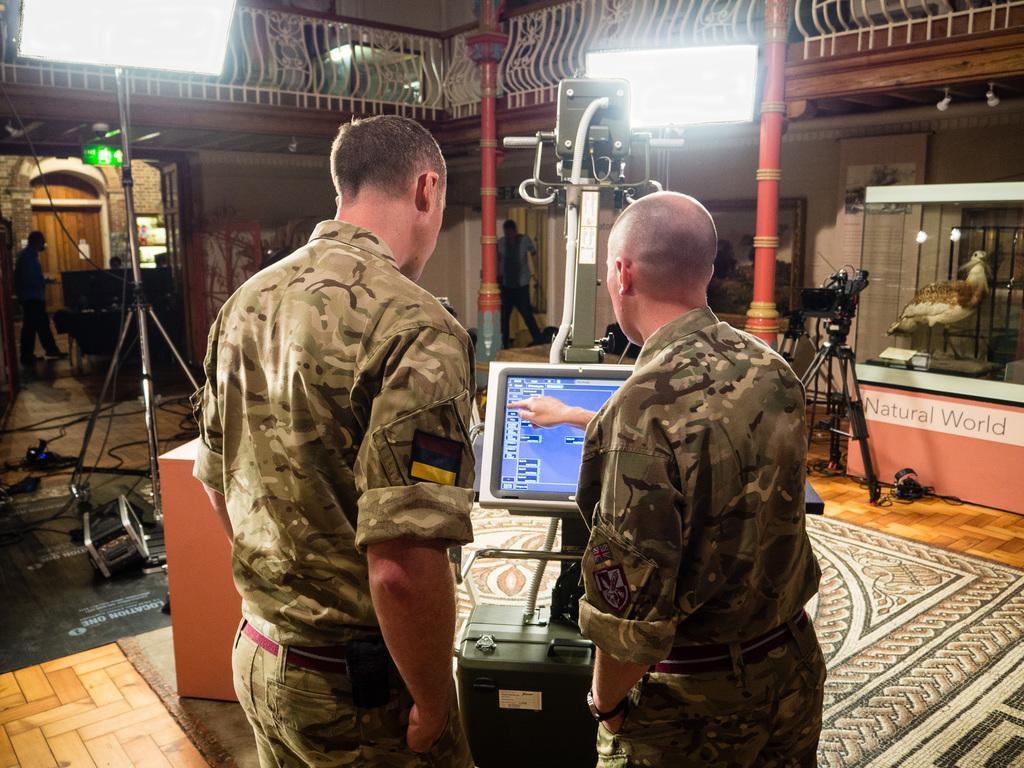Please provide a concise description of this image. in this image I can see two people standing and wearing the military uniforms. In-front of these people I can see the screen. In the background I can see few more people and some objects. These people are standing inside the house. To the side I can see the bird which is in white and brown color. I can also see the lights in the back. 